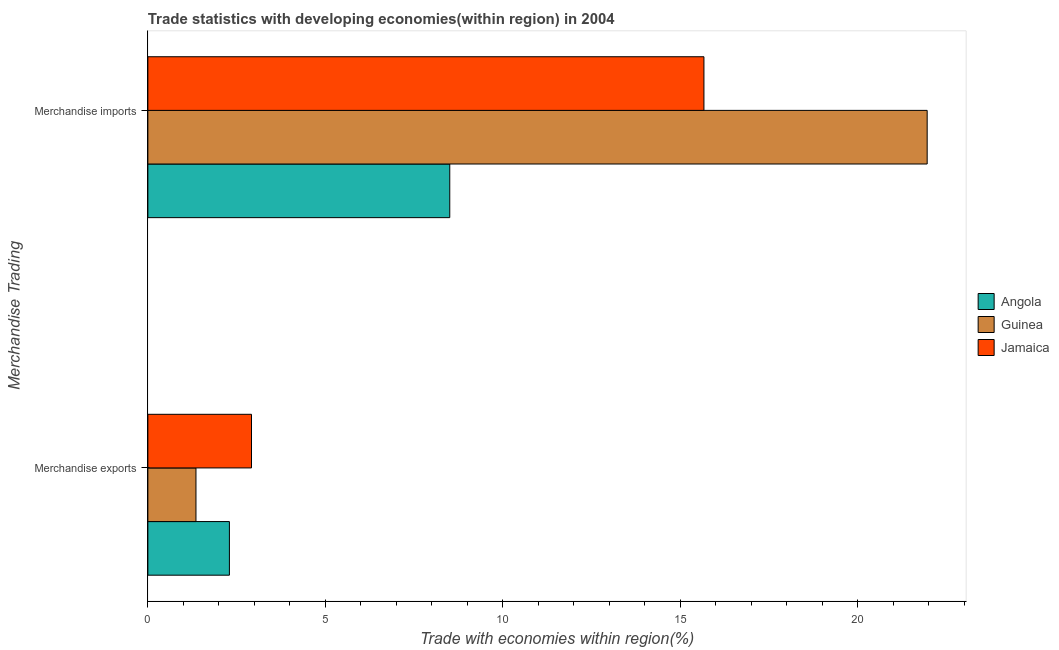How many groups of bars are there?
Your response must be concise. 2. How many bars are there on the 2nd tick from the top?
Keep it short and to the point. 3. How many bars are there on the 1st tick from the bottom?
Your answer should be compact. 3. What is the label of the 1st group of bars from the top?
Provide a short and direct response. Merchandise imports. What is the merchandise exports in Jamaica?
Your answer should be very brief. 2.92. Across all countries, what is the maximum merchandise imports?
Your response must be concise. 21.95. Across all countries, what is the minimum merchandise exports?
Keep it short and to the point. 1.35. In which country was the merchandise imports maximum?
Your answer should be compact. Guinea. In which country was the merchandise imports minimum?
Offer a very short reply. Angola. What is the total merchandise exports in the graph?
Your answer should be compact. 6.57. What is the difference between the merchandise exports in Jamaica and that in Guinea?
Make the answer very short. 1.56. What is the difference between the merchandise exports in Angola and the merchandise imports in Guinea?
Give a very brief answer. -19.65. What is the average merchandise imports per country?
Offer a terse response. 15.37. What is the difference between the merchandise exports and merchandise imports in Angola?
Offer a terse response. -6.21. In how many countries, is the merchandise exports greater than 8 %?
Your answer should be very brief. 0. What is the ratio of the merchandise imports in Jamaica to that in Angola?
Your answer should be compact. 1.84. What does the 3rd bar from the top in Merchandise imports represents?
Give a very brief answer. Angola. What does the 3rd bar from the bottom in Merchandise exports represents?
Offer a very short reply. Jamaica. Are all the bars in the graph horizontal?
Your answer should be very brief. Yes. Does the graph contain any zero values?
Provide a short and direct response. No. Where does the legend appear in the graph?
Ensure brevity in your answer.  Center right. How are the legend labels stacked?
Provide a succinct answer. Vertical. What is the title of the graph?
Your response must be concise. Trade statistics with developing economies(within region) in 2004. Does "Denmark" appear as one of the legend labels in the graph?
Your answer should be compact. No. What is the label or title of the X-axis?
Ensure brevity in your answer.  Trade with economies within region(%). What is the label or title of the Y-axis?
Your answer should be compact. Merchandise Trading. What is the Trade with economies within region(%) of Angola in Merchandise exports?
Ensure brevity in your answer.  2.3. What is the Trade with economies within region(%) in Guinea in Merchandise exports?
Offer a very short reply. 1.35. What is the Trade with economies within region(%) in Jamaica in Merchandise exports?
Provide a short and direct response. 2.92. What is the Trade with economies within region(%) in Angola in Merchandise imports?
Offer a terse response. 8.5. What is the Trade with economies within region(%) in Guinea in Merchandise imports?
Provide a succinct answer. 21.95. What is the Trade with economies within region(%) of Jamaica in Merchandise imports?
Offer a very short reply. 15.66. Across all Merchandise Trading, what is the maximum Trade with economies within region(%) of Angola?
Your response must be concise. 8.5. Across all Merchandise Trading, what is the maximum Trade with economies within region(%) of Guinea?
Make the answer very short. 21.95. Across all Merchandise Trading, what is the maximum Trade with economies within region(%) of Jamaica?
Offer a terse response. 15.66. Across all Merchandise Trading, what is the minimum Trade with economies within region(%) of Angola?
Your answer should be compact. 2.3. Across all Merchandise Trading, what is the minimum Trade with economies within region(%) in Guinea?
Your answer should be very brief. 1.35. Across all Merchandise Trading, what is the minimum Trade with economies within region(%) in Jamaica?
Offer a very short reply. 2.92. What is the total Trade with economies within region(%) in Angola in the graph?
Give a very brief answer. 10.8. What is the total Trade with economies within region(%) in Guinea in the graph?
Your response must be concise. 23.3. What is the total Trade with economies within region(%) in Jamaica in the graph?
Offer a very short reply. 18.58. What is the difference between the Trade with economies within region(%) in Angola in Merchandise exports and that in Merchandise imports?
Your answer should be very brief. -6.21. What is the difference between the Trade with economies within region(%) in Guinea in Merchandise exports and that in Merchandise imports?
Your response must be concise. -20.59. What is the difference between the Trade with economies within region(%) of Jamaica in Merchandise exports and that in Merchandise imports?
Provide a short and direct response. -12.74. What is the difference between the Trade with economies within region(%) in Angola in Merchandise exports and the Trade with economies within region(%) in Guinea in Merchandise imports?
Your answer should be compact. -19.65. What is the difference between the Trade with economies within region(%) in Angola in Merchandise exports and the Trade with economies within region(%) in Jamaica in Merchandise imports?
Provide a short and direct response. -13.37. What is the difference between the Trade with economies within region(%) in Guinea in Merchandise exports and the Trade with economies within region(%) in Jamaica in Merchandise imports?
Your response must be concise. -14.31. What is the average Trade with economies within region(%) of Angola per Merchandise Trading?
Keep it short and to the point. 5.4. What is the average Trade with economies within region(%) in Guinea per Merchandise Trading?
Provide a succinct answer. 11.65. What is the average Trade with economies within region(%) in Jamaica per Merchandise Trading?
Offer a terse response. 9.29. What is the difference between the Trade with economies within region(%) in Angola and Trade with economies within region(%) in Guinea in Merchandise exports?
Provide a short and direct response. 0.94. What is the difference between the Trade with economies within region(%) of Angola and Trade with economies within region(%) of Jamaica in Merchandise exports?
Provide a short and direct response. -0.62. What is the difference between the Trade with economies within region(%) of Guinea and Trade with economies within region(%) of Jamaica in Merchandise exports?
Make the answer very short. -1.56. What is the difference between the Trade with economies within region(%) in Angola and Trade with economies within region(%) in Guinea in Merchandise imports?
Your answer should be compact. -13.45. What is the difference between the Trade with economies within region(%) of Angola and Trade with economies within region(%) of Jamaica in Merchandise imports?
Your answer should be very brief. -7.16. What is the difference between the Trade with economies within region(%) of Guinea and Trade with economies within region(%) of Jamaica in Merchandise imports?
Provide a short and direct response. 6.29. What is the ratio of the Trade with economies within region(%) of Angola in Merchandise exports to that in Merchandise imports?
Give a very brief answer. 0.27. What is the ratio of the Trade with economies within region(%) of Guinea in Merchandise exports to that in Merchandise imports?
Make the answer very short. 0.06. What is the ratio of the Trade with economies within region(%) in Jamaica in Merchandise exports to that in Merchandise imports?
Your answer should be compact. 0.19. What is the difference between the highest and the second highest Trade with economies within region(%) of Angola?
Give a very brief answer. 6.21. What is the difference between the highest and the second highest Trade with economies within region(%) in Guinea?
Ensure brevity in your answer.  20.59. What is the difference between the highest and the second highest Trade with economies within region(%) in Jamaica?
Your answer should be very brief. 12.74. What is the difference between the highest and the lowest Trade with economies within region(%) in Angola?
Your answer should be compact. 6.21. What is the difference between the highest and the lowest Trade with economies within region(%) of Guinea?
Your answer should be very brief. 20.59. What is the difference between the highest and the lowest Trade with economies within region(%) in Jamaica?
Offer a terse response. 12.74. 